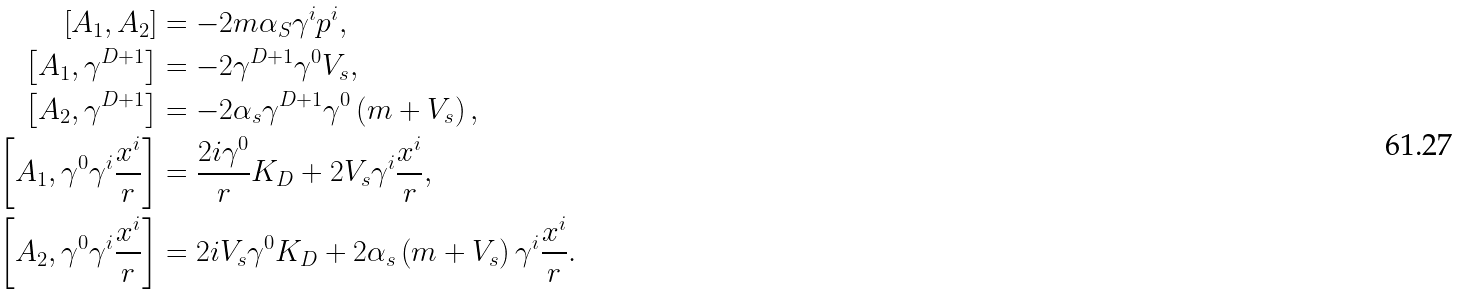Convert formula to latex. <formula><loc_0><loc_0><loc_500><loc_500>\left [ A _ { 1 } , A _ { 2 } \right ] & = - 2 m \alpha _ { S } \gamma ^ { i } p ^ { i } , \\ \left [ A _ { 1 } , \gamma ^ { D + 1 } \right ] & = - 2 \gamma ^ { D + 1 } \gamma ^ { 0 } V _ { s } , \\ \left [ A _ { 2 } , \gamma ^ { D + 1 } \right ] & = - 2 \alpha _ { s } \gamma ^ { D + 1 } \gamma ^ { 0 } \left ( m + V _ { s } \right ) , \\ \left [ A _ { 1 } , \gamma ^ { 0 } \gamma ^ { i } \frac { x ^ { i } } { r } \right ] & = \frac { 2 i \gamma ^ { 0 } } { r } K _ { D } + 2 V _ { s } \gamma ^ { i } \frac { x ^ { i } } { r } , \\ \left [ A _ { 2 } , \gamma ^ { 0 } \gamma ^ { i } \frac { x ^ { i } } { r } \right ] & = 2 i V _ { s } \gamma ^ { 0 } K _ { D } + 2 \alpha _ { s } \left ( m + V _ { s } \right ) \gamma ^ { i } \frac { x ^ { i } } { r } .</formula> 